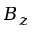<formula> <loc_0><loc_0><loc_500><loc_500>B _ { z }</formula> 